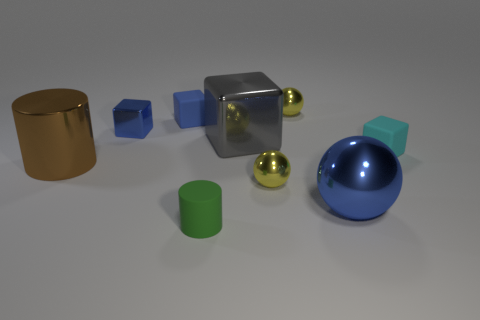Subtract all green cylinders. How many cylinders are left? 1 Subtract all large spheres. How many spheres are left? 2 Subtract 0 gray cylinders. How many objects are left? 9 Subtract all cylinders. How many objects are left? 7 Subtract 4 cubes. How many cubes are left? 0 Subtract all yellow cubes. Subtract all brown cylinders. How many cubes are left? 4 Subtract all red balls. How many blue blocks are left? 2 Subtract all large green metallic cubes. Subtract all big blocks. How many objects are left? 8 Add 5 matte objects. How many matte objects are left? 8 Add 5 large things. How many large things exist? 8 